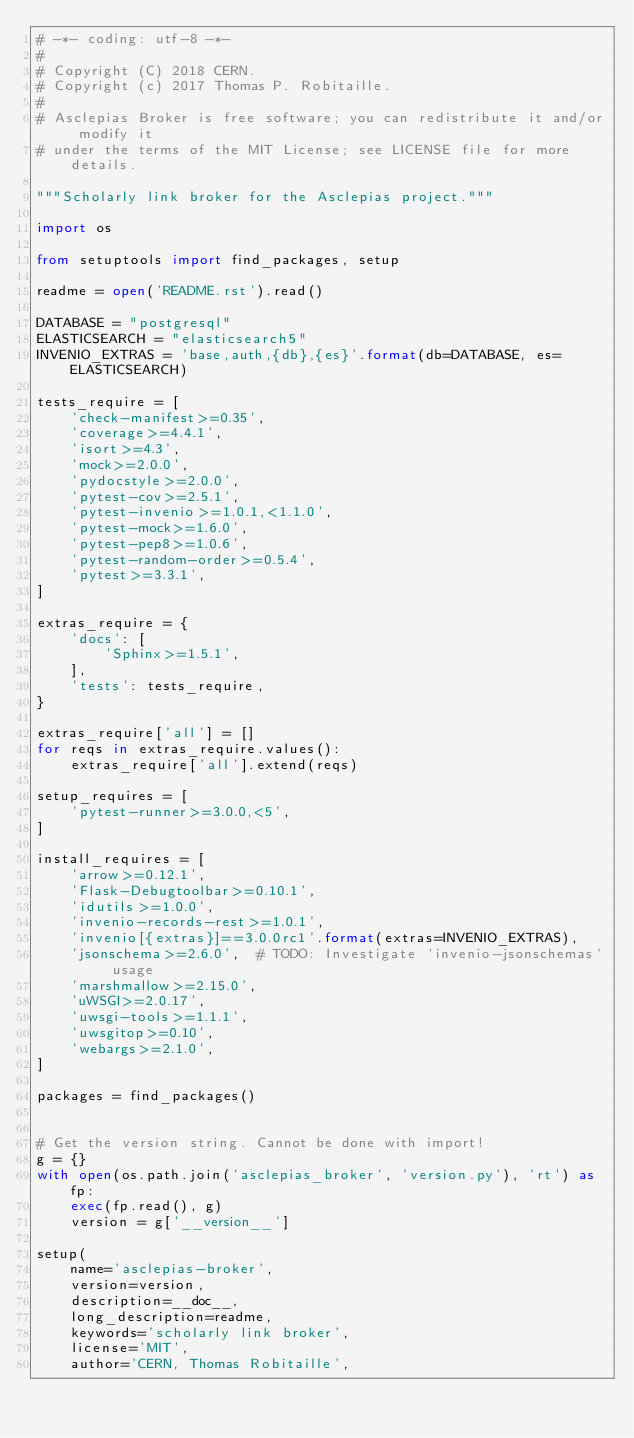Convert code to text. <code><loc_0><loc_0><loc_500><loc_500><_Python_># -*- coding: utf-8 -*-
#
# Copyright (C) 2018 CERN.
# Copyright (c) 2017 Thomas P. Robitaille.
#
# Asclepias Broker is free software; you can redistribute it and/or modify it
# under the terms of the MIT License; see LICENSE file for more details.

"""Scholarly link broker for the Asclepias project."""

import os

from setuptools import find_packages, setup

readme = open('README.rst').read()

DATABASE = "postgresql"
ELASTICSEARCH = "elasticsearch5"
INVENIO_EXTRAS = 'base,auth,{db},{es}'.format(db=DATABASE, es=ELASTICSEARCH)

tests_require = [
    'check-manifest>=0.35',
    'coverage>=4.4.1',
    'isort>=4.3',
    'mock>=2.0.0',
    'pydocstyle>=2.0.0',
    'pytest-cov>=2.5.1',
    'pytest-invenio>=1.0.1,<1.1.0',
    'pytest-mock>=1.6.0',
    'pytest-pep8>=1.0.6',
    'pytest-random-order>=0.5.4',
    'pytest>=3.3.1',
]

extras_require = {
    'docs': [
        'Sphinx>=1.5.1',
    ],
    'tests': tests_require,
}

extras_require['all'] = []
for reqs in extras_require.values():
    extras_require['all'].extend(reqs)

setup_requires = [
    'pytest-runner>=3.0.0,<5',
]

install_requires = [
    'arrow>=0.12.1',
    'Flask-Debugtoolbar>=0.10.1',
    'idutils>=1.0.0',
    'invenio-records-rest>=1.0.1',
    'invenio[{extras}]==3.0.0rc1'.format(extras=INVENIO_EXTRAS),
    'jsonschema>=2.6.0',  # TODO: Investigate `invenio-jsonschemas` usage
    'marshmallow>=2.15.0',
    'uWSGI>=2.0.17',
    'uwsgi-tools>=1.1.1',
    'uwsgitop>=0.10',
    'webargs>=2.1.0',
]

packages = find_packages()


# Get the version string. Cannot be done with import!
g = {}
with open(os.path.join('asclepias_broker', 'version.py'), 'rt') as fp:
    exec(fp.read(), g)
    version = g['__version__']

setup(
    name='asclepias-broker',
    version=version,
    description=__doc__,
    long_description=readme,
    keywords='scholarly link broker',
    license='MIT',
    author='CERN, Thomas Robitaille',</code> 